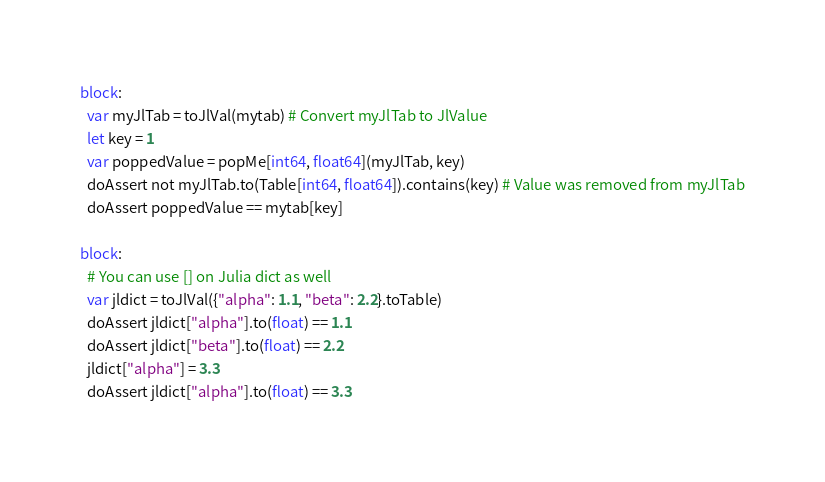<code> <loc_0><loc_0><loc_500><loc_500><_Nim_>
block:
  var myJlTab = toJlVal(mytab) # Convert myJlTab to JlValue
  let key = 1
  var poppedValue = popMe[int64, float64](myJlTab, key)
  doAssert not myJlTab.to(Table[int64, float64]).contains(key) # Value was removed from myJlTab
  doAssert poppedValue == mytab[key]

block:
  # You can use [] on Julia dict as well
  var jldict = toJlVal({"alpha": 1.1, "beta": 2.2}.toTable)
  doAssert jldict["alpha"].to(float) == 1.1
  doAssert jldict["beta"].to(float) == 2.2
  jldict["alpha"] = 3.3
  doAssert jldict["alpha"].to(float) == 3.3

</code> 